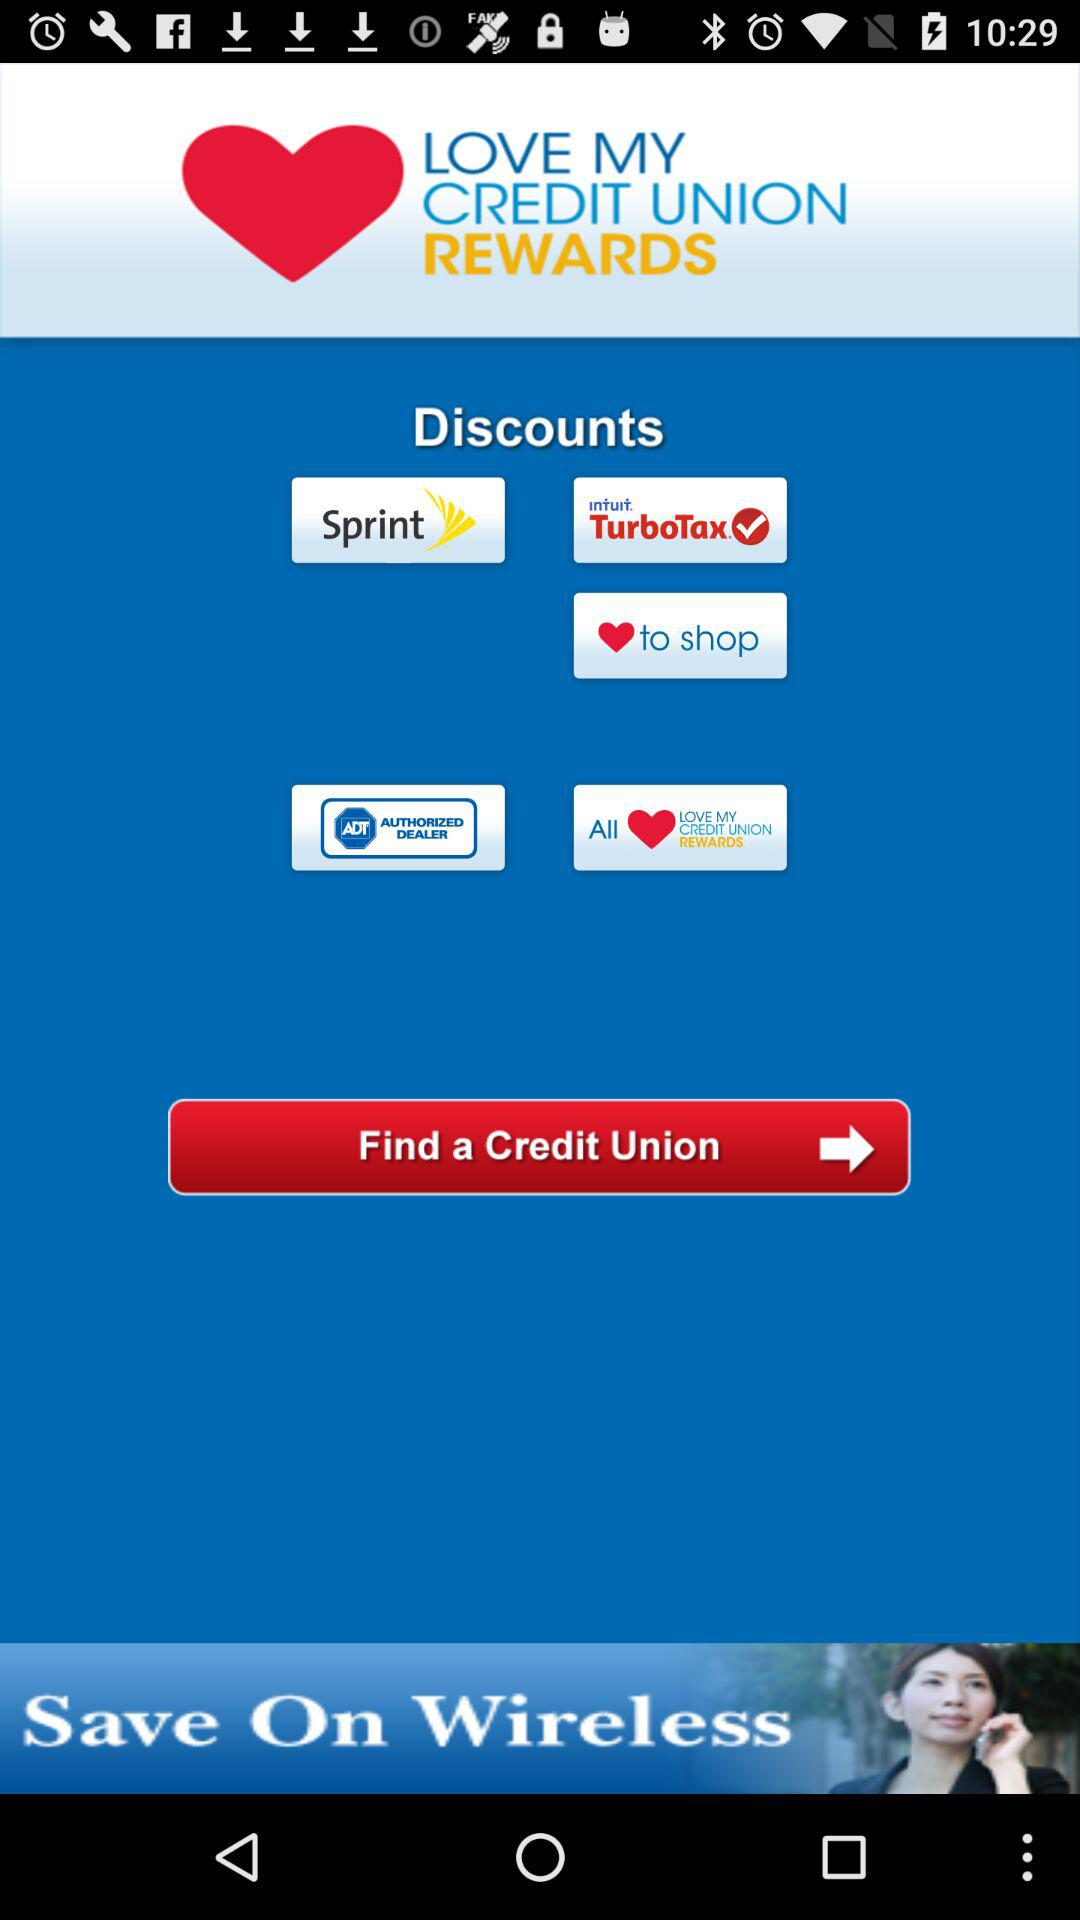What is the name of the application? The name of the application is "LOVE MY CREDIT UNION REWARDS". 